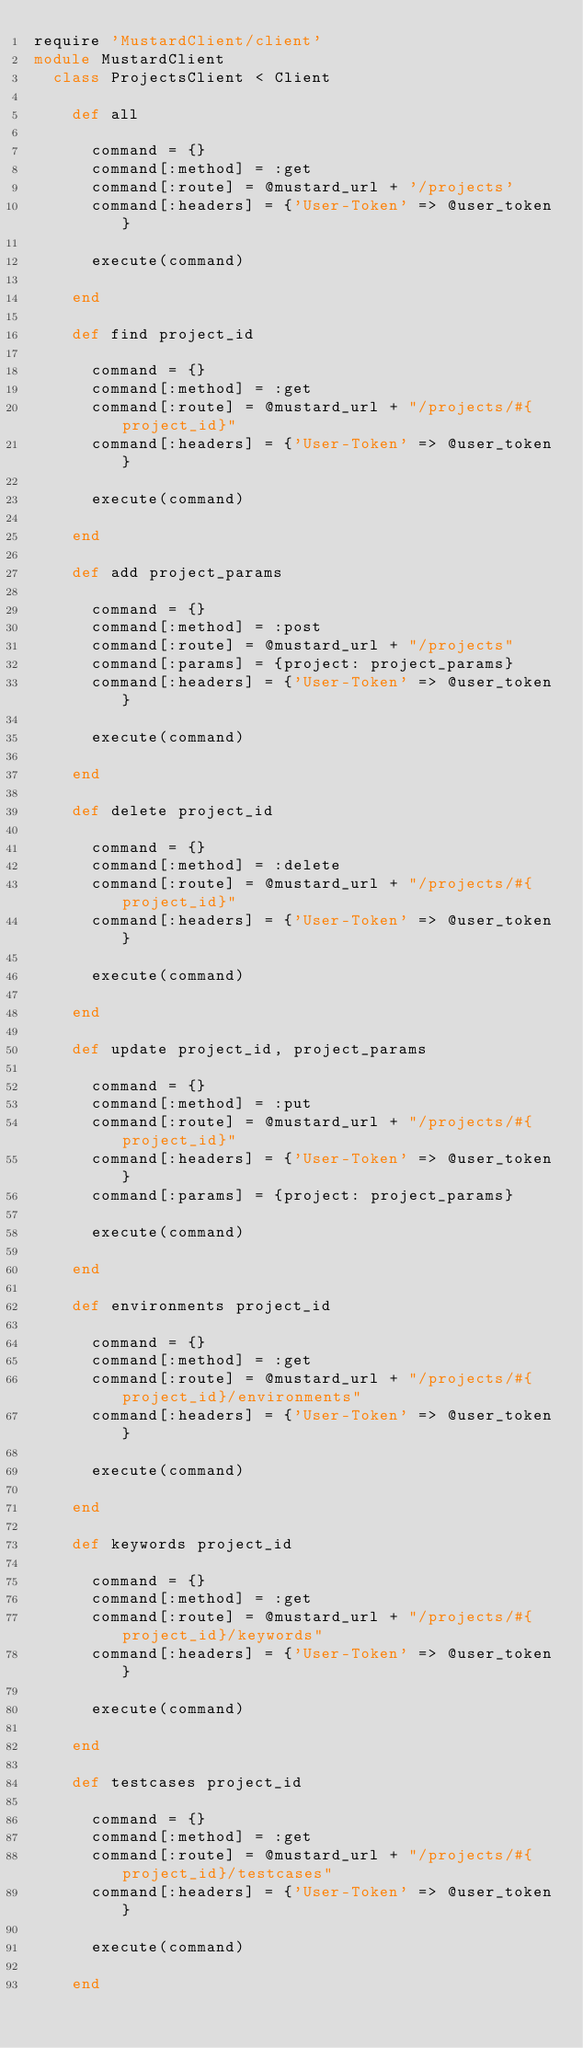<code> <loc_0><loc_0><loc_500><loc_500><_Ruby_>require 'MustardClient/client'
module MustardClient
  class ProjectsClient < Client

    def all

      command = {}
      command[:method] = :get
      command[:route] = @mustard_url + '/projects'
      command[:headers] = {'User-Token' => @user_token}

      execute(command)

    end

    def find project_id

      command = {}
      command[:method] = :get
      command[:route] = @mustard_url + "/projects/#{project_id}"
      command[:headers] = {'User-Token' => @user_token}

      execute(command)

    end

    def add project_params

      command = {}
      command[:method] = :post
      command[:route] = @mustard_url + "/projects"
      command[:params] = {project: project_params}
      command[:headers] = {'User-Token' => @user_token}

      execute(command)

    end

    def delete project_id

      command = {}
      command[:method] = :delete
      command[:route] = @mustard_url + "/projects/#{project_id}"
      command[:headers] = {'User-Token' => @user_token}

      execute(command)

    end

    def update project_id, project_params

      command = {}
      command[:method] = :put
      command[:route] = @mustard_url + "/projects/#{project_id}"
      command[:headers] = {'User-Token' => @user_token}
      command[:params] = {project: project_params}

      execute(command)

    end

    def environments project_id

      command = {}
      command[:method] = :get
      command[:route] = @mustard_url + "/projects/#{project_id}/environments"
      command[:headers] = {'User-Token' => @user_token}

      execute(command)

    end

    def keywords project_id

      command = {}
      command[:method] = :get
      command[:route] = @mustard_url + "/projects/#{project_id}/keywords"
      command[:headers] = {'User-Token' => @user_token}

      execute(command)

    end

    def testcases project_id

      command = {}
      command[:method] = :get
      command[:route] = @mustard_url + "/projects/#{project_id}/testcases"
      command[:headers] = {'User-Token' => @user_token}

      execute(command)

    end
</code> 